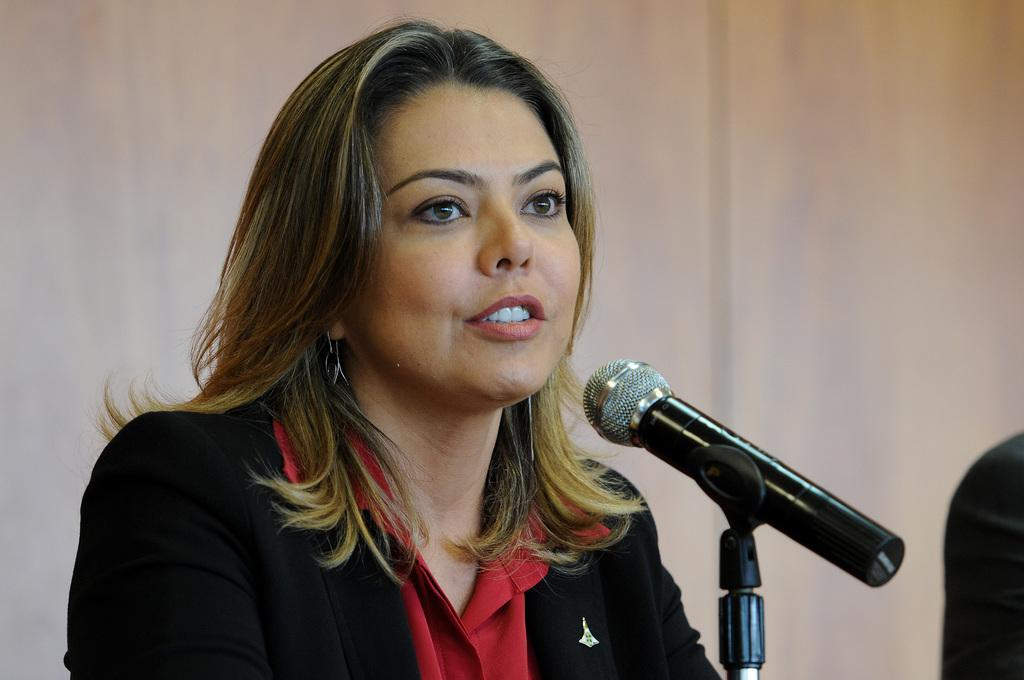What is the dog doing with the ball in the image? The dog is playing with a ball in the image. What color is the dog in the image? The dog is brown in color. How does the dog slip on the loaf while playing with the ball in the image? There is no loaf present in the image, and the dog is not shown slipping while playing with the ball. 